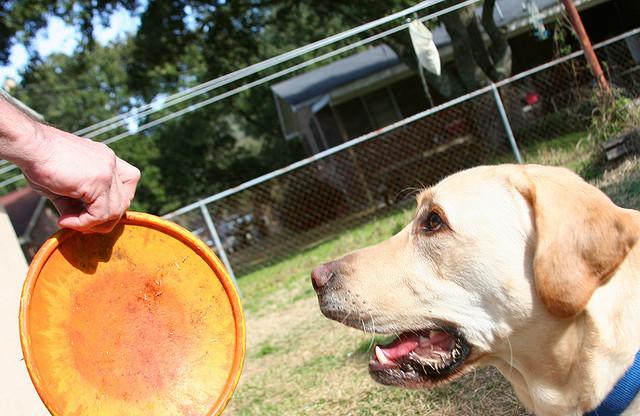How many dogs do you see?
Be succinct. 1. What color is the frisbee?
Short answer required. Orange. What animal is this?
Write a very short answer. Dog. 